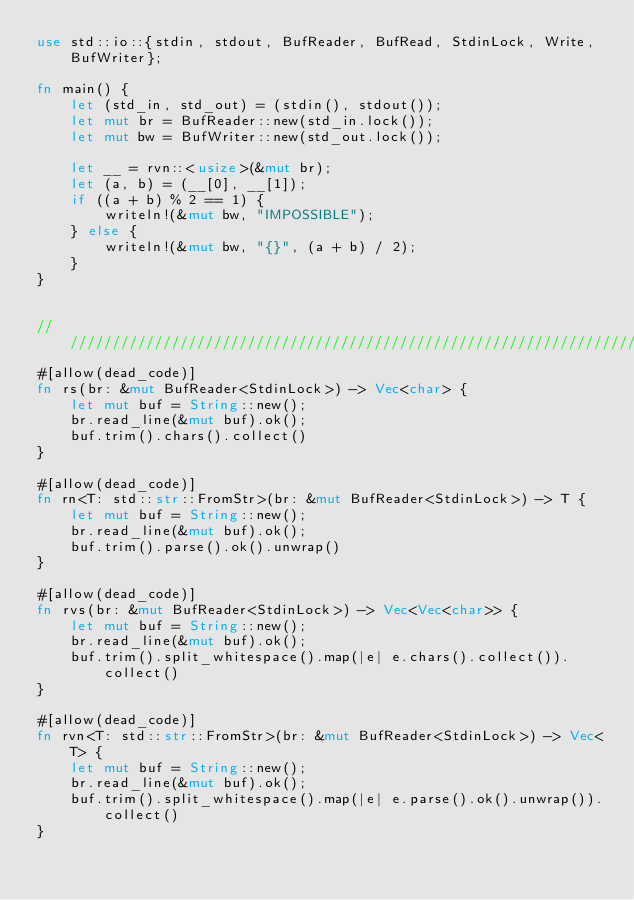Convert code to text. <code><loc_0><loc_0><loc_500><loc_500><_Rust_>use std::io::{stdin, stdout, BufReader, BufRead, StdinLock, Write, BufWriter};

fn main() {
    let (std_in, std_out) = (stdin(), stdout());
    let mut br = BufReader::new(std_in.lock());
    let mut bw = BufWriter::new(std_out.lock());
    
    let __ = rvn::<usize>(&mut br);
    let (a, b) = (__[0], __[1]);
    if ((a + b) % 2 == 1) {
        writeln!(&mut bw, "IMPOSSIBLE");
    } else {
        writeln!(&mut bw, "{}", (a + b) / 2);
    }
}


//////////////////////////////////////////////////////////////////////////////////
#[allow(dead_code)]
fn rs(br: &mut BufReader<StdinLock>) -> Vec<char> {
    let mut buf = String::new();
    br.read_line(&mut buf).ok();
    buf.trim().chars().collect()
}

#[allow(dead_code)]
fn rn<T: std::str::FromStr>(br: &mut BufReader<StdinLock>) -> T {
    let mut buf = String::new();
    br.read_line(&mut buf).ok();
    buf.trim().parse().ok().unwrap()
}

#[allow(dead_code)]
fn rvs(br: &mut BufReader<StdinLock>) -> Vec<Vec<char>> {
    let mut buf = String::new();
    br.read_line(&mut buf).ok();
    buf.trim().split_whitespace().map(|e| e.chars().collect()).collect()
}

#[allow(dead_code)]
fn rvn<T: std::str::FromStr>(br: &mut BufReader<StdinLock>) -> Vec<T> {
    let mut buf = String::new();
    br.read_line(&mut buf).ok();
    buf.trim().split_whitespace().map(|e| e.parse().ok().unwrap()).collect()
}</code> 